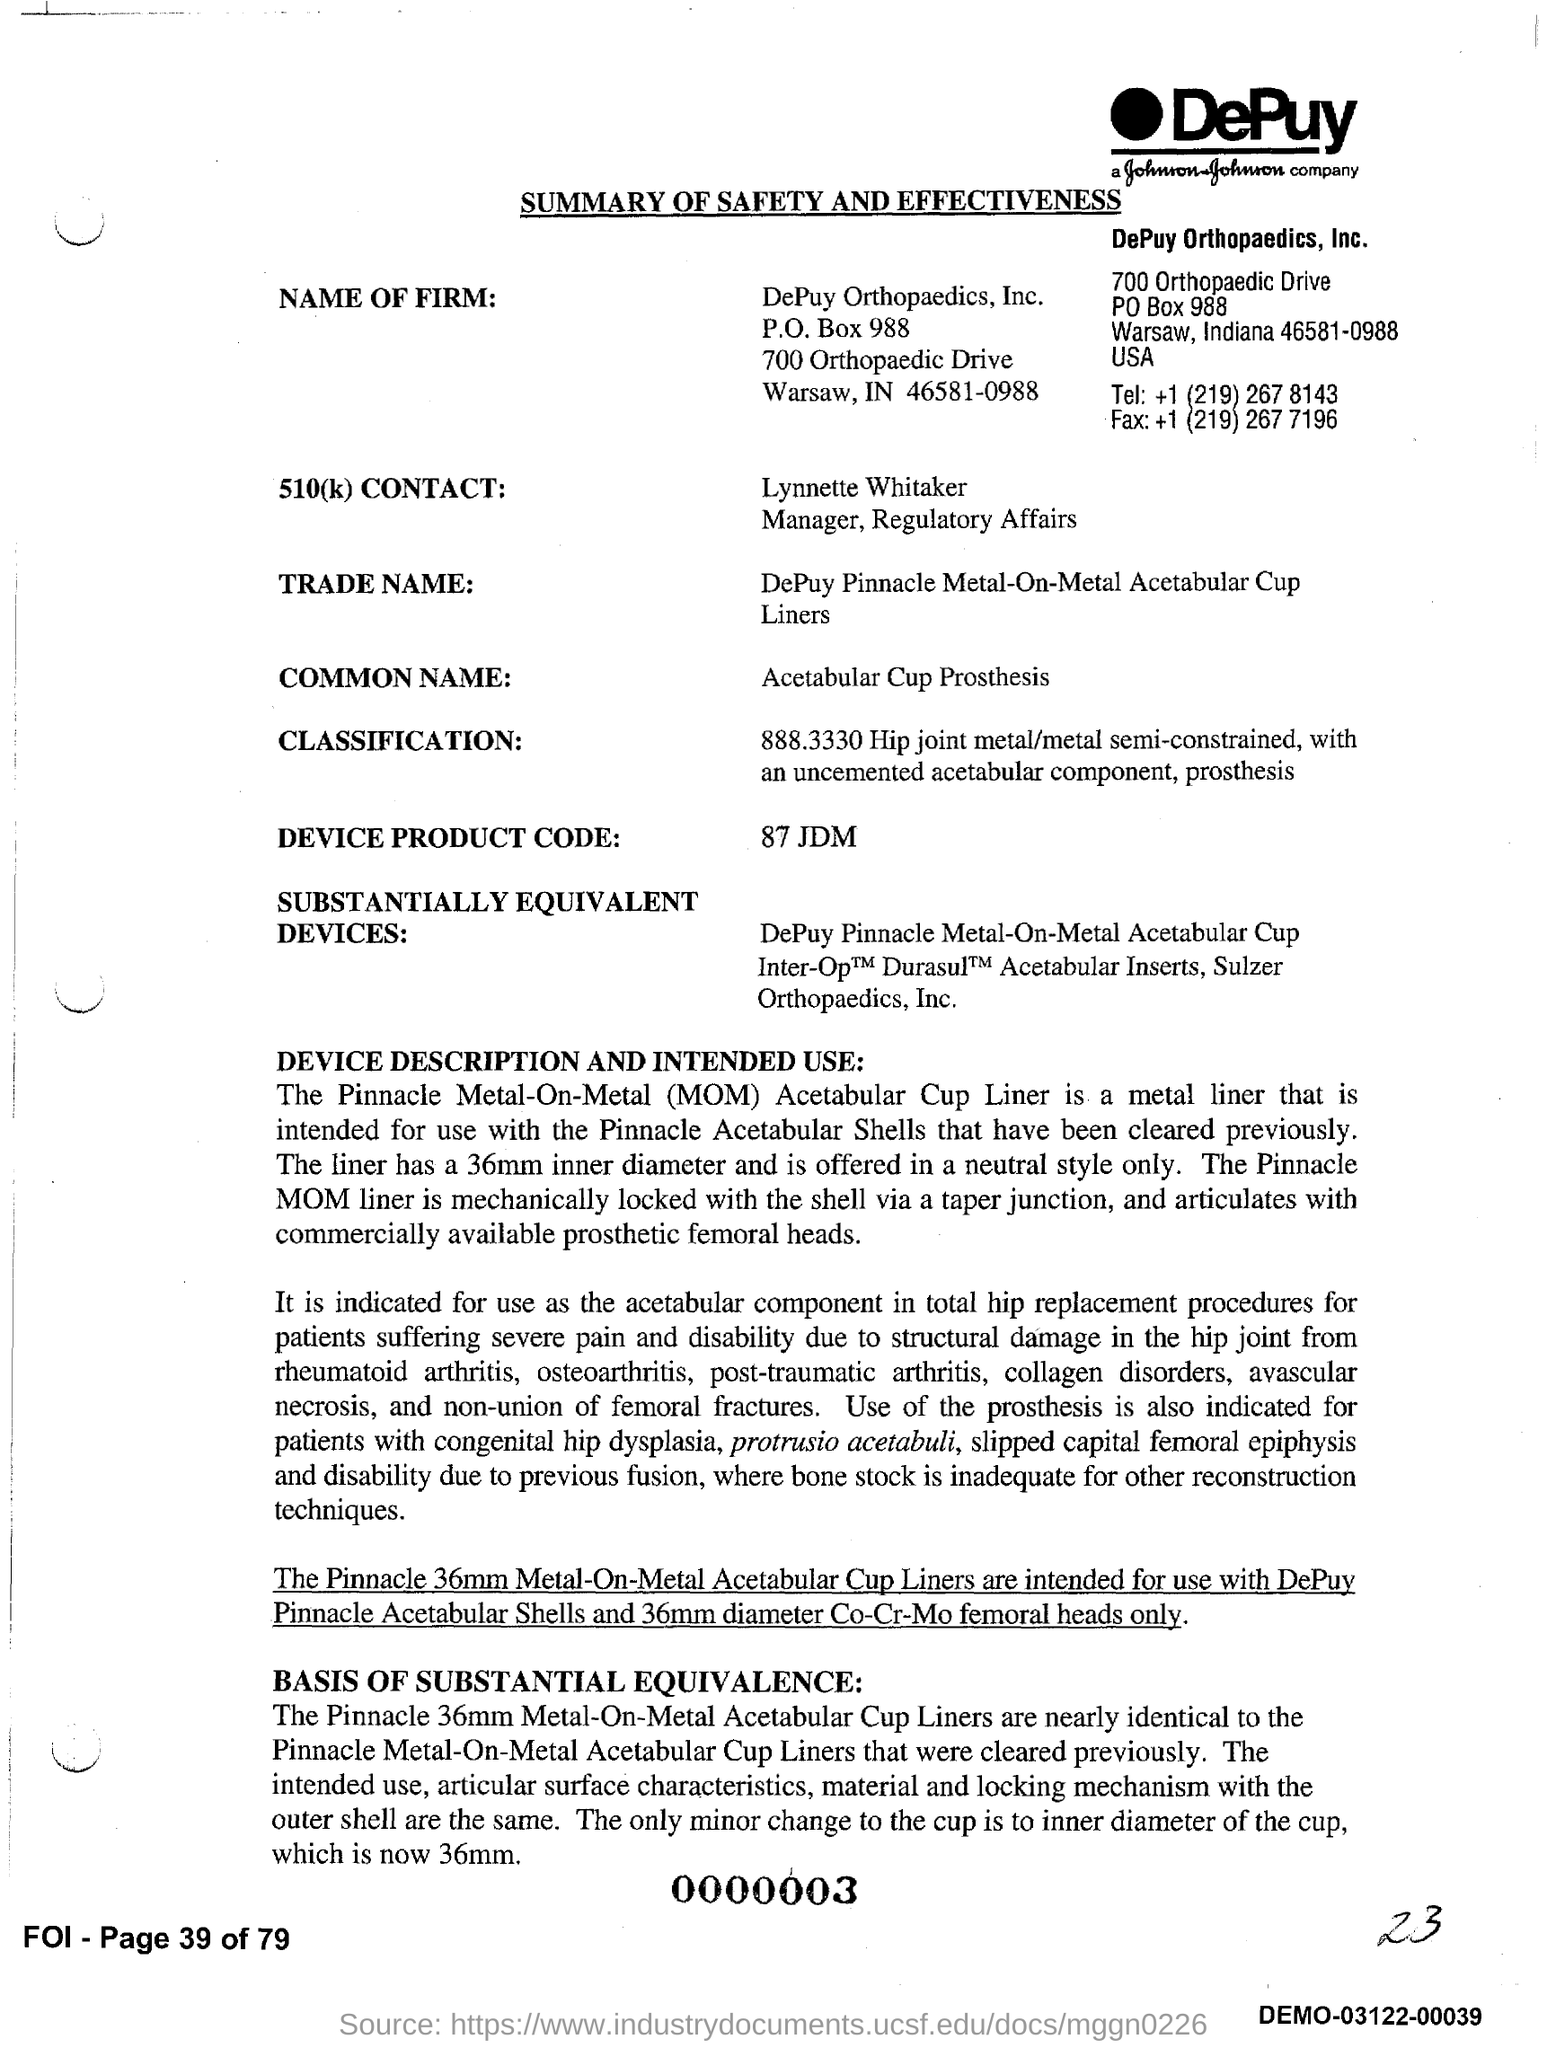What is the document title?
Provide a succinct answer. SUMMARY OF SAFETY AND EFFECTIVENESS. What is the name of the firm?
Offer a very short reply. DePuy Orthopaedics, Inc. What is the common name of the product?
Your answer should be very brief. Acetabular Cup Prosthesis. What is the device product code?
Ensure brevity in your answer.  87 JDM. Who is Lynnette Whitaker?
Your response must be concise. Manager. What is the trade name of the product?
Offer a terse response. DePuy Pinnacle Metal-On-Metal Acetabular Cup Liners. What is the Tel number given?
Offer a terse response. +1 (219) 267 8143. 